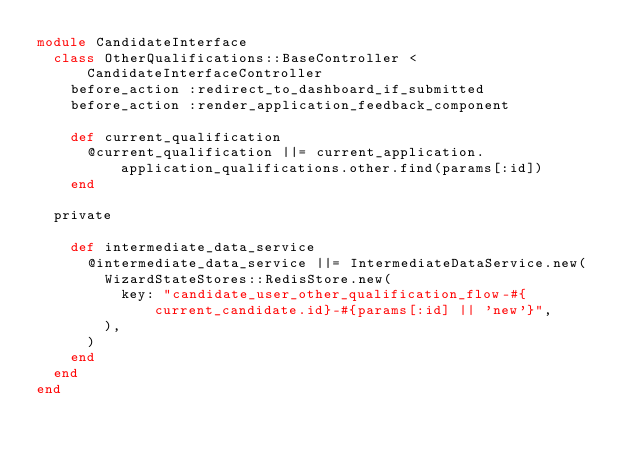<code> <loc_0><loc_0><loc_500><loc_500><_Ruby_>module CandidateInterface
  class OtherQualifications::BaseController < CandidateInterfaceController
    before_action :redirect_to_dashboard_if_submitted
    before_action :render_application_feedback_component

    def current_qualification
      @current_qualification ||= current_application.application_qualifications.other.find(params[:id])
    end

  private

    def intermediate_data_service
      @intermediate_data_service ||= IntermediateDataService.new(
        WizardStateStores::RedisStore.new(
          key: "candidate_user_other_qualification_flow-#{current_candidate.id}-#{params[:id] || 'new'}",
        ),
      )
    end
  end
end
</code> 